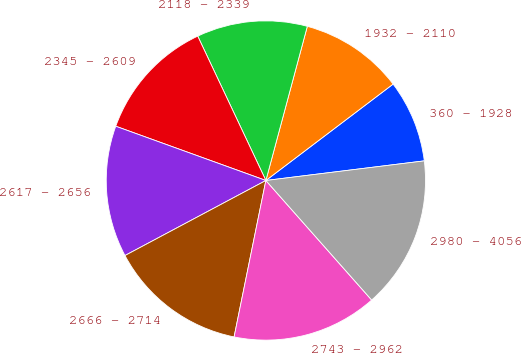<chart> <loc_0><loc_0><loc_500><loc_500><pie_chart><fcel>360 - 1928<fcel>1932 - 2110<fcel>2118 - 2339<fcel>2345 - 2609<fcel>2617 - 2656<fcel>2666 - 2714<fcel>2743 - 2962<fcel>2980 - 4056<nl><fcel>8.36%<fcel>10.5%<fcel>11.2%<fcel>12.46%<fcel>13.31%<fcel>14.02%<fcel>14.72%<fcel>15.43%<nl></chart> 